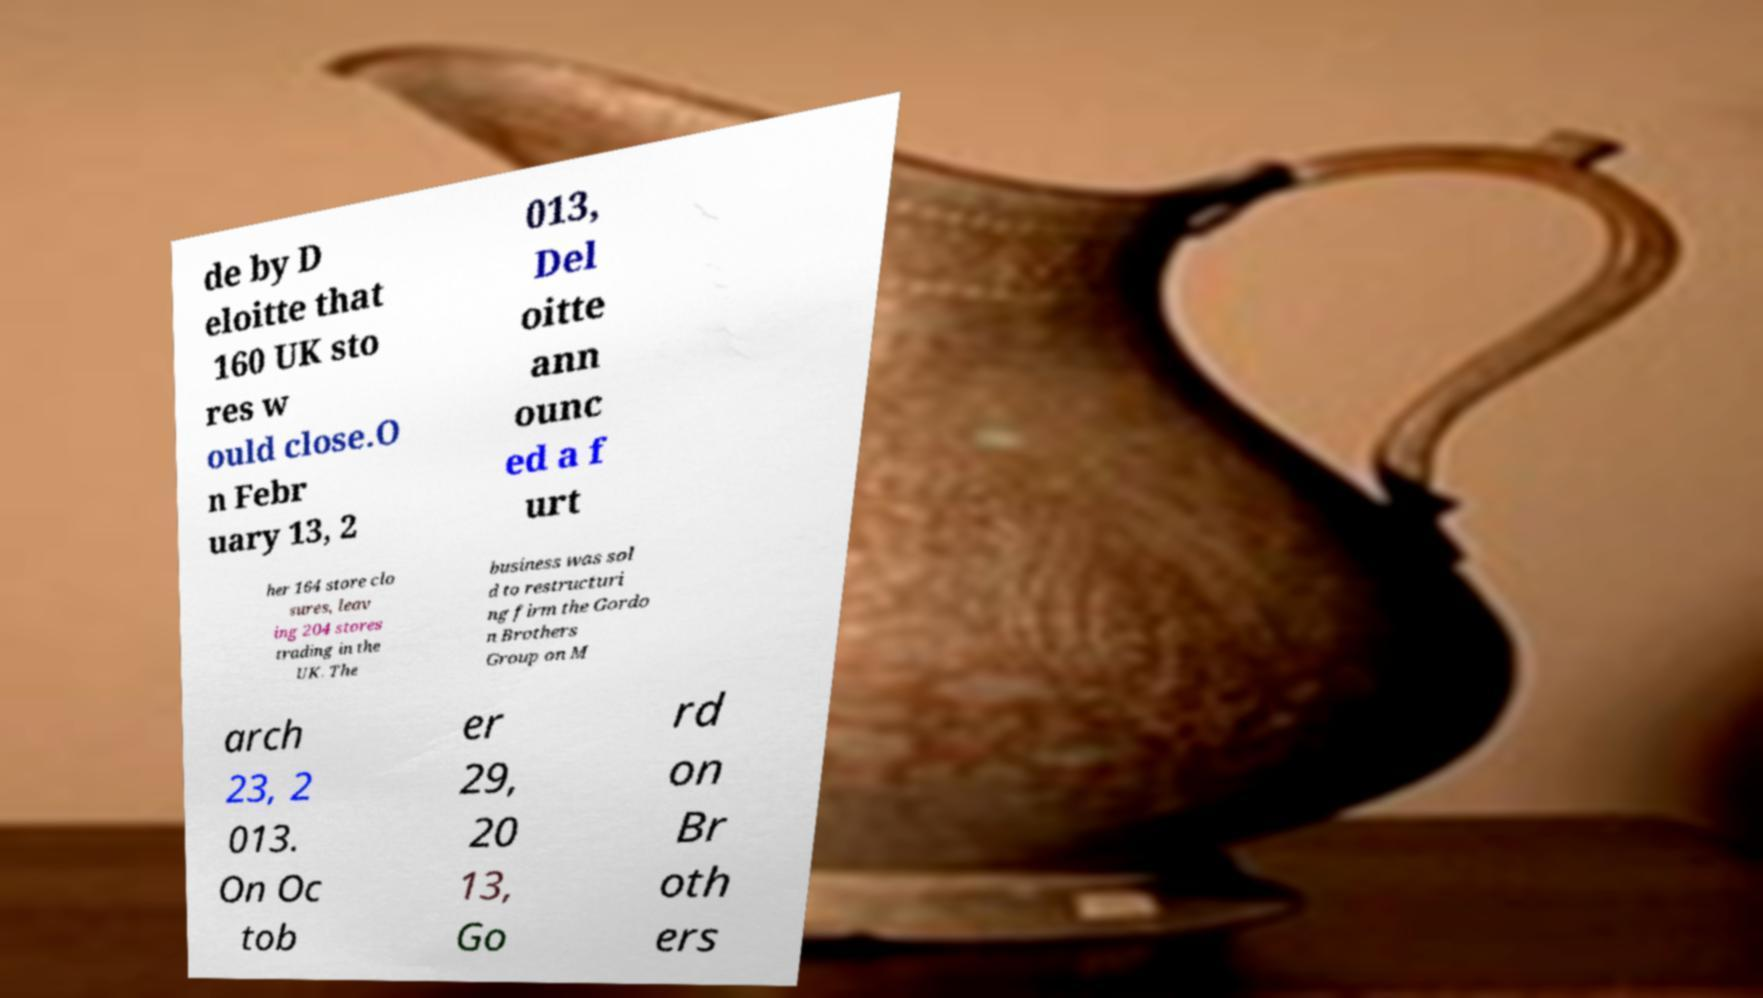Please identify and transcribe the text found in this image. de by D eloitte that 160 UK sto res w ould close.O n Febr uary 13, 2 013, Del oitte ann ounc ed a f urt her 164 store clo sures, leav ing 204 stores trading in the UK. The business was sol d to restructuri ng firm the Gordo n Brothers Group on M arch 23, 2 013. On Oc tob er 29, 20 13, Go rd on Br oth ers 